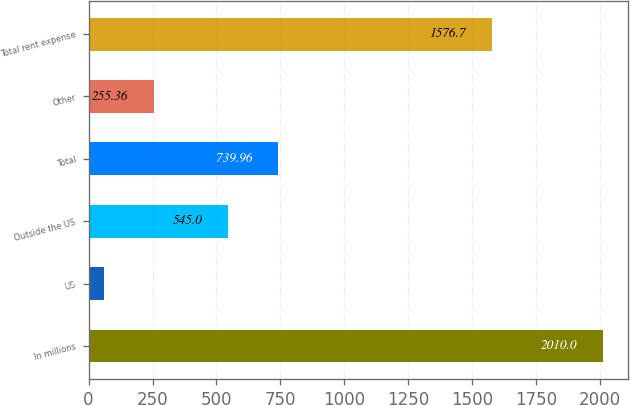<chart> <loc_0><loc_0><loc_500><loc_500><bar_chart><fcel>In millions<fcel>US<fcel>Outside the US<fcel>Total<fcel>Other<fcel>Total rent expense<nl><fcel>2010<fcel>60.4<fcel>545<fcel>739.96<fcel>255.36<fcel>1576.7<nl></chart> 